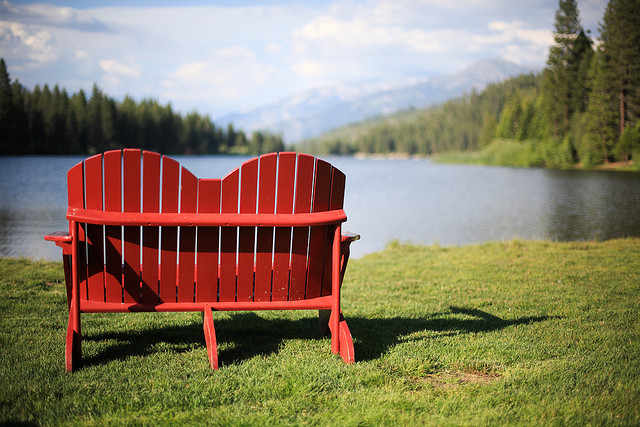Pretend you are writing a postcard from here. Describe what you see and feel. Dear Friend, 

Greetings from this beautiful lakeside haven! The view here is absolutely stunning. The calm waters of the lake reflect the surrounding trees and mountains, creating a mirror-like effect that is both soothing and inspiring. The red bench I'm sitting on offers a perfect spot to take it all in. There's a gentle breeze and the sound of birds chirping in the distance, making this a truly idyllic escape from the hustle and bustle of everyday life. I wish you could be here to experience this serene beauty with me. 

Best regards, 
[Your Name] 